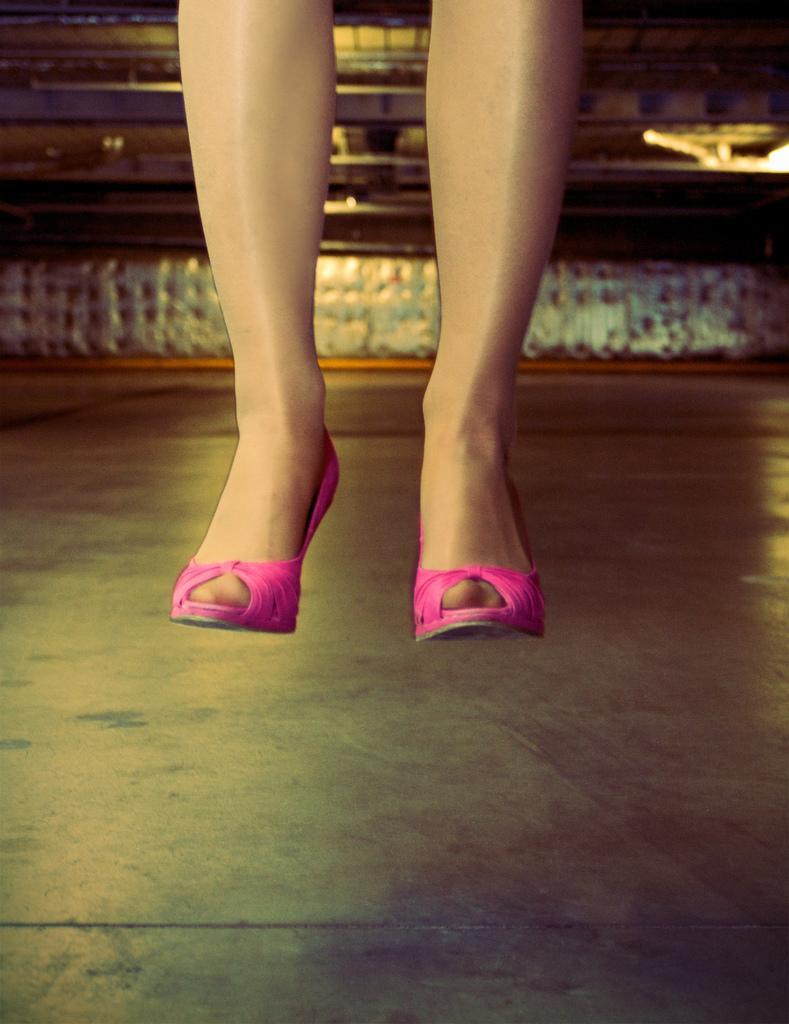How would you summarize this image in a sentence or two? This image is an edited image. This image is taken indoors. At the bottom of the image there is a floor. In the background there is a wall and in the middle of the image there are two legs of a person. On the right side of the image there is a light. 